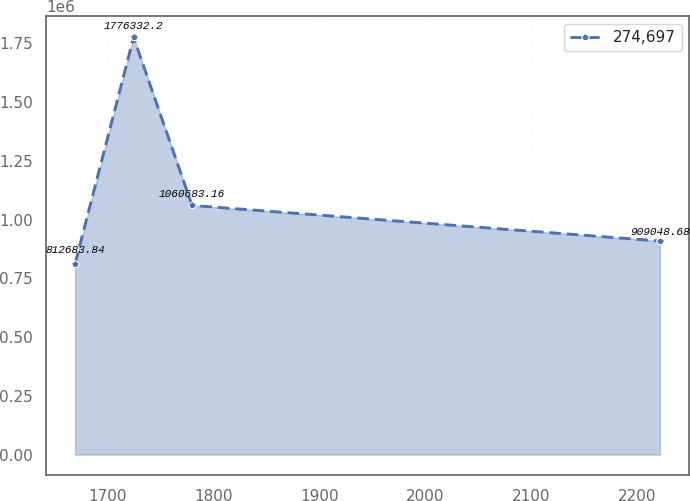Convert chart to OTSL. <chart><loc_0><loc_0><loc_500><loc_500><line_chart><ecel><fcel>274,697<nl><fcel>1669.47<fcel>812684<nl><fcel>1724.7<fcel>1.77633e+06<nl><fcel>1779.93<fcel>1.06068e+06<nl><fcel>2221.73<fcel>909049<nl></chart> 